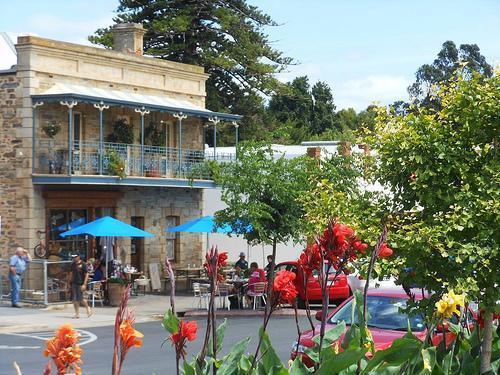How many umbrellas are visible?
Give a very brief answer. 2. 